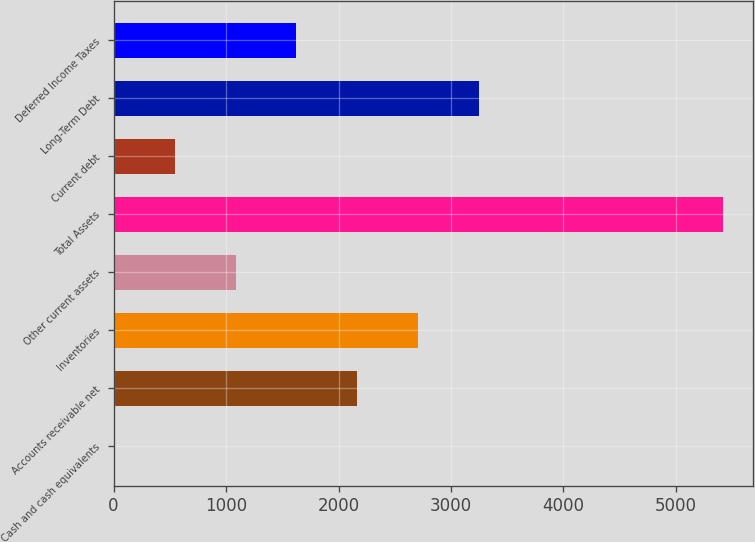Convert chart to OTSL. <chart><loc_0><loc_0><loc_500><loc_500><bar_chart><fcel>Cash and cash equivalents<fcel>Accounts receivable net<fcel>Inventories<fcel>Other current assets<fcel>Total Assets<fcel>Current debt<fcel>Long-Term Debt<fcel>Deferred Income Taxes<nl><fcel>1<fcel>2167.8<fcel>2709.5<fcel>1084.4<fcel>5418<fcel>542.7<fcel>3251.2<fcel>1626.1<nl></chart> 